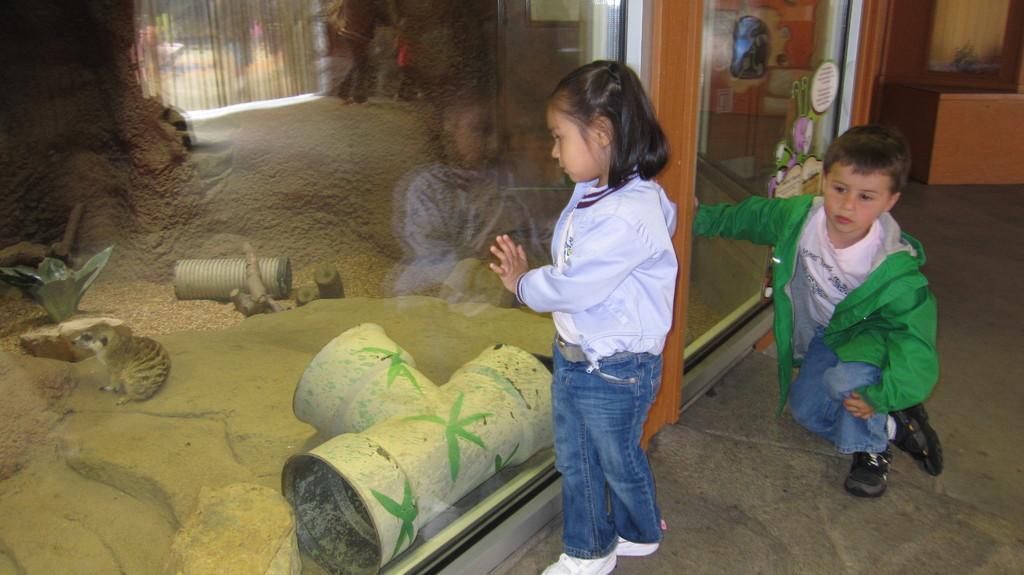Please provide a concise description of this image. In the center of the image there are two kids. To the left side of image there is glass. At the bottom image there is flooring. 